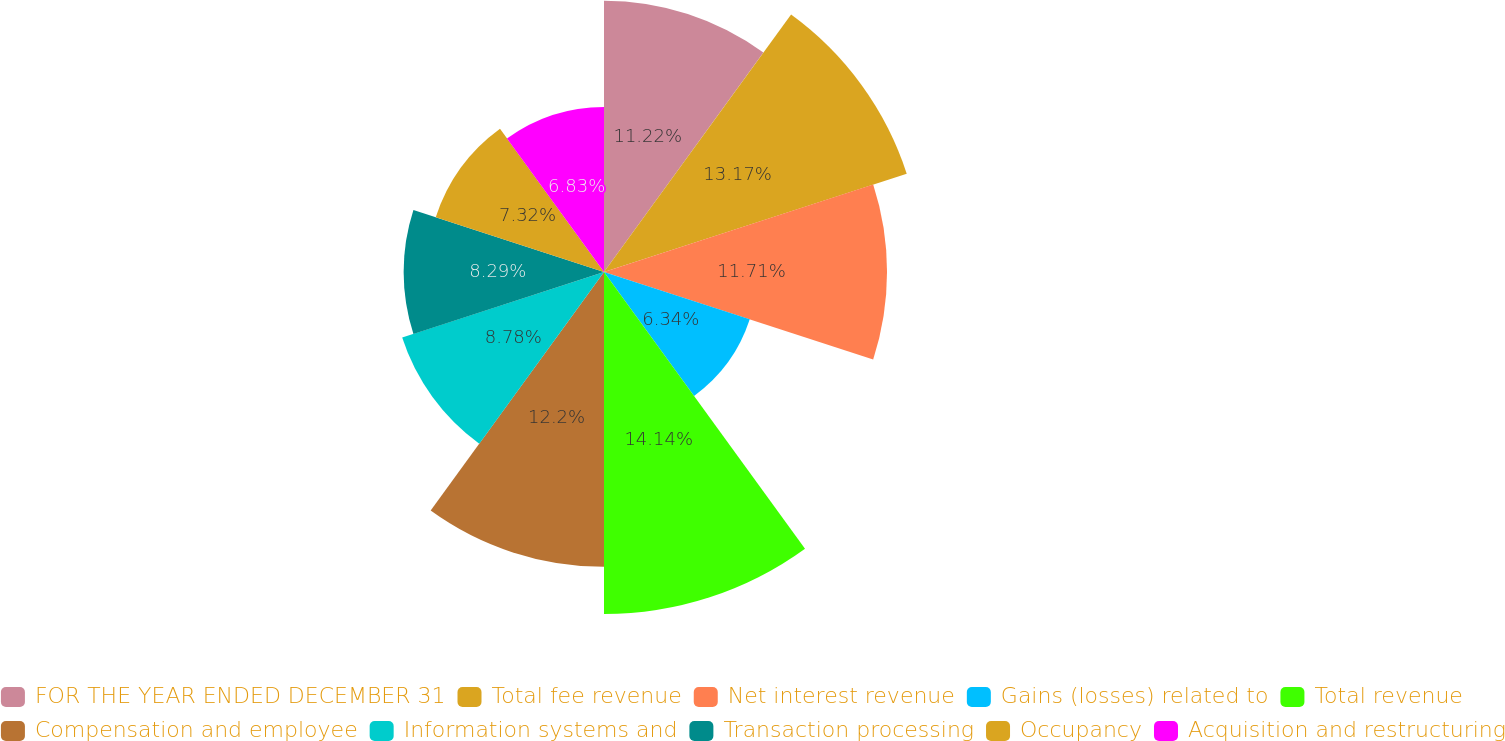Convert chart to OTSL. <chart><loc_0><loc_0><loc_500><loc_500><pie_chart><fcel>FOR THE YEAR ENDED DECEMBER 31<fcel>Total fee revenue<fcel>Net interest revenue<fcel>Gains (losses) related to<fcel>Total revenue<fcel>Compensation and employee<fcel>Information systems and<fcel>Transaction processing<fcel>Occupancy<fcel>Acquisition and restructuring<nl><fcel>11.22%<fcel>13.17%<fcel>11.71%<fcel>6.34%<fcel>14.15%<fcel>12.2%<fcel>8.78%<fcel>8.29%<fcel>7.32%<fcel>6.83%<nl></chart> 